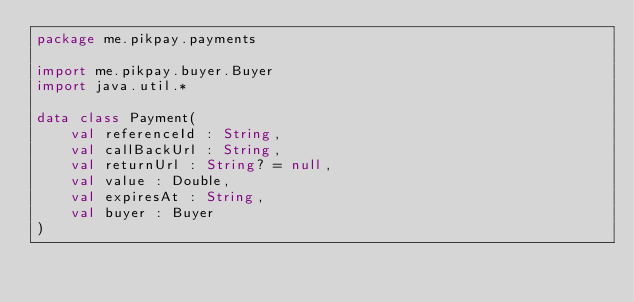<code> <loc_0><loc_0><loc_500><loc_500><_Kotlin_>package me.pikpay.payments

import me.pikpay.buyer.Buyer
import java.util.*

data class Payment(
    val referenceId : String,
    val callBackUrl : String,
    val returnUrl : String? = null,
    val value : Double,
    val expiresAt : String,
    val buyer : Buyer
)</code> 